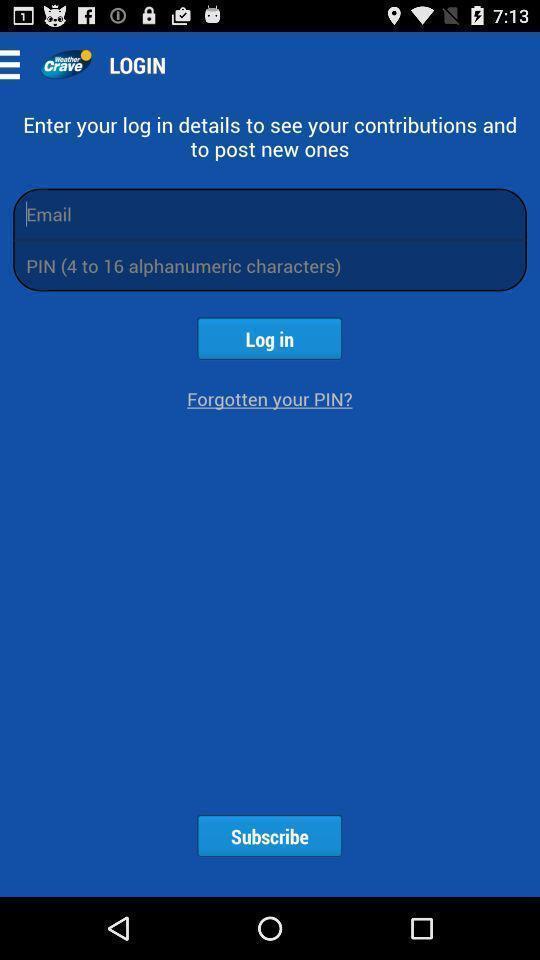Tell me what you see in this picture. Login page. 